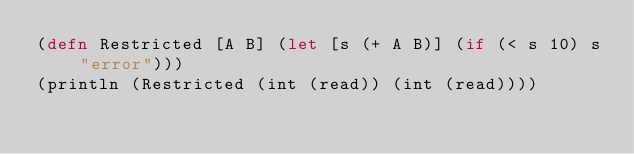<code> <loc_0><loc_0><loc_500><loc_500><_Clojure_>(defn Restricted [A B] (let [s (+ A B)] (if (< s 10) s "error")))
(println (Restricted (int (read)) (int (read))))</code> 